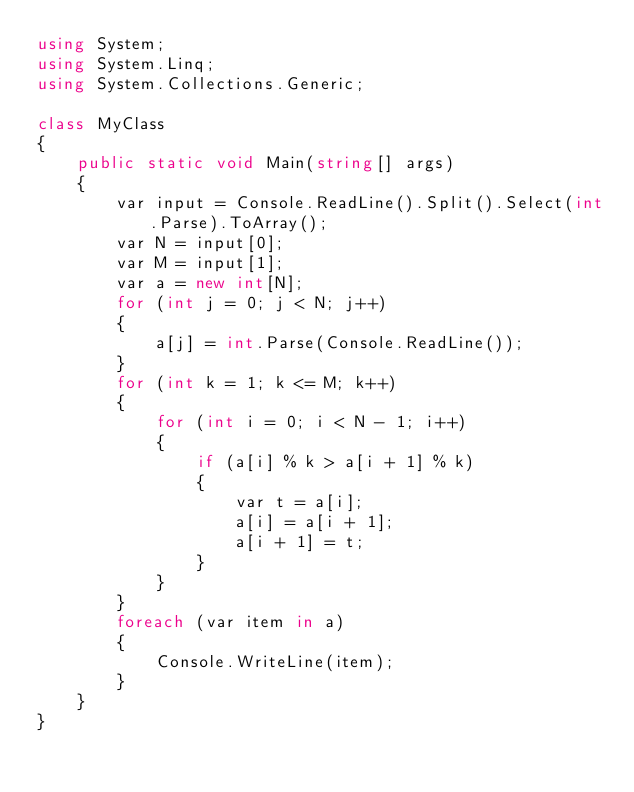<code> <loc_0><loc_0><loc_500><loc_500><_C#_>using System;
using System.Linq;
using System.Collections.Generic;

class MyClass
{
    public static void Main(string[] args)
    {
        var input = Console.ReadLine().Split().Select(int.Parse).ToArray();
        var N = input[0];
        var M = input[1];
        var a = new int[N];
        for (int j = 0; j < N; j++)
        {
            a[j] = int.Parse(Console.ReadLine());
        }
        for (int k = 1; k <= M; k++)
        {
            for (int i = 0; i < N - 1; i++)
            {
                if (a[i] % k > a[i + 1] % k)
                {
                    var t = a[i];
                    a[i] = a[i + 1];
                    a[i + 1] = t;
                }
            }
        }
        foreach (var item in a)
        {
            Console.WriteLine(item);
        }
    }
}
</code> 